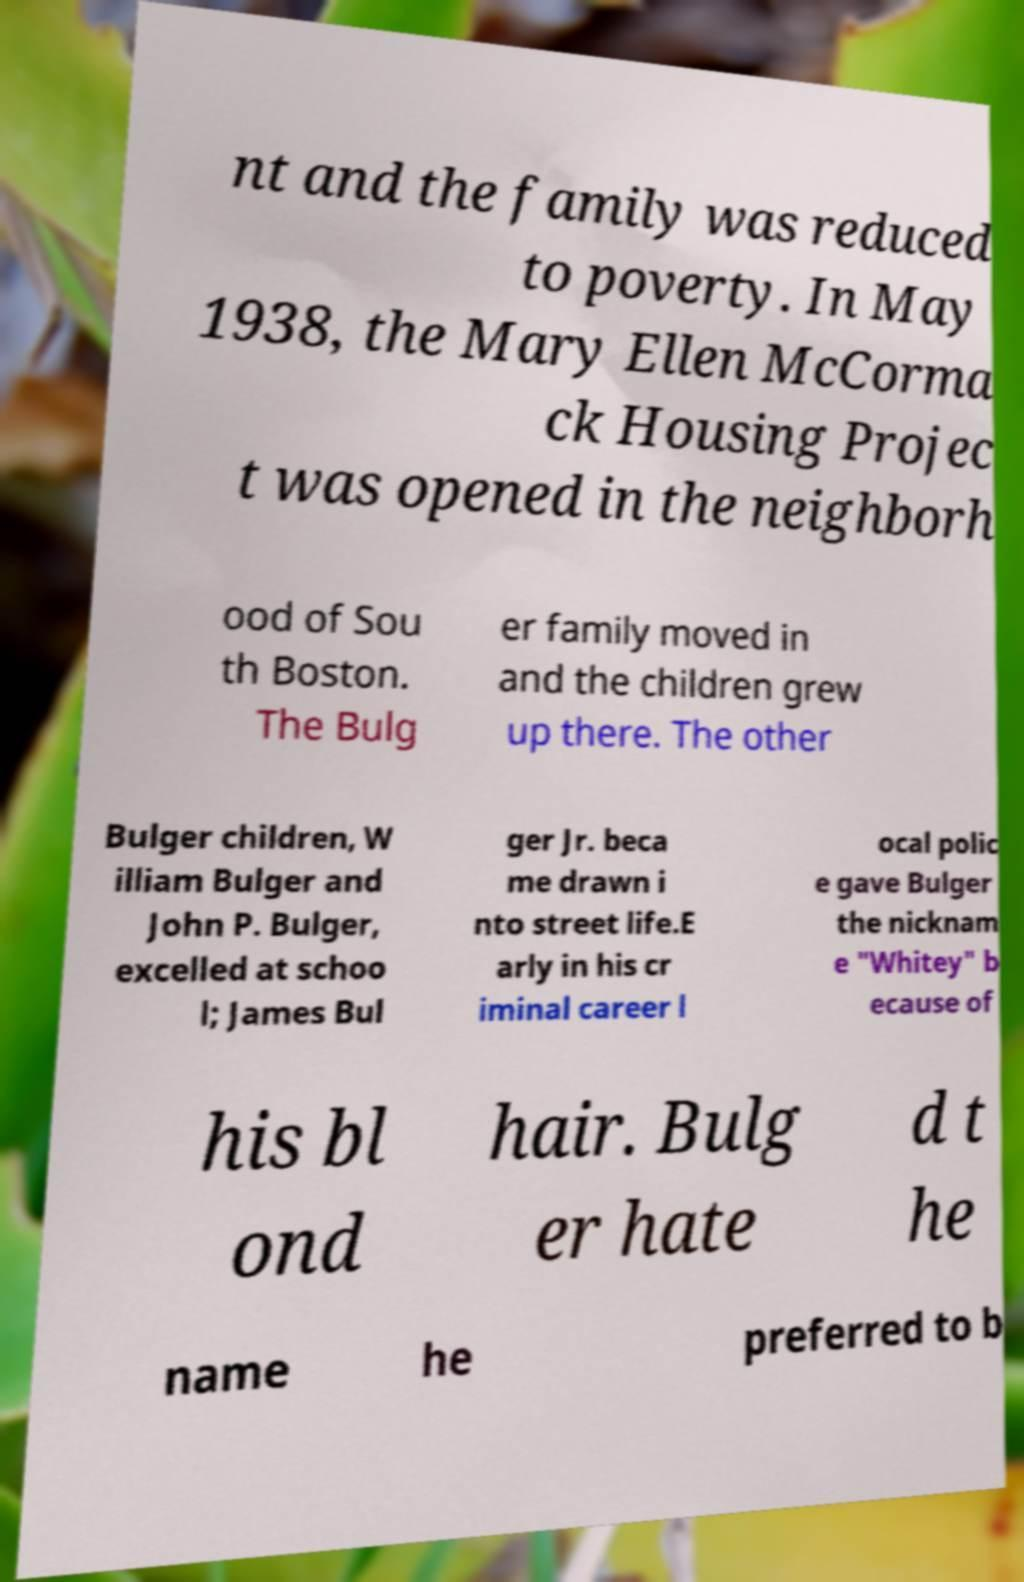What messages or text are displayed in this image? I need them in a readable, typed format. nt and the family was reduced to poverty. In May 1938, the Mary Ellen McCorma ck Housing Projec t was opened in the neighborh ood of Sou th Boston. The Bulg er family moved in and the children grew up there. The other Bulger children, W illiam Bulger and John P. Bulger, excelled at schoo l; James Bul ger Jr. beca me drawn i nto street life.E arly in his cr iminal career l ocal polic e gave Bulger the nicknam e "Whitey" b ecause of his bl ond hair. Bulg er hate d t he name he preferred to b 